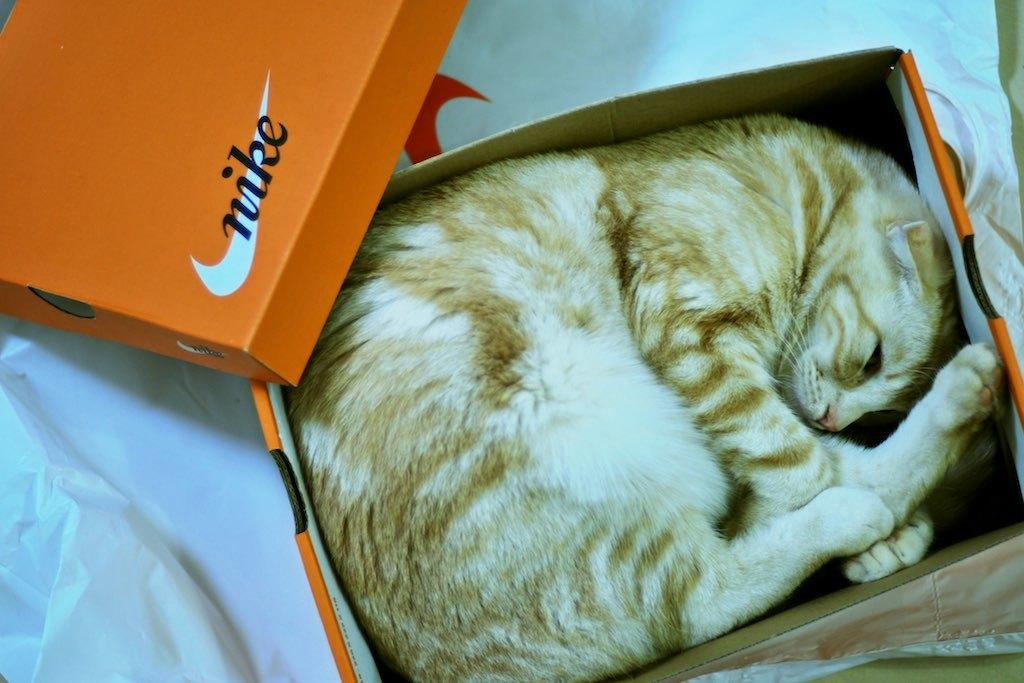What type of animal is in the image? There is a cat in the image. What is the cat doing in the image? The cat is sleeping. Where is the cat located in the image? The cat is in a cardboard box. What is at the bottom of the box? There is a cover at the bottom of the box. How does the cat transport itself to different locations in the image? The cat does not transport itself in the image; it is in a stationary position in the cardboard box. What type of hearing aid is the cat wearing in the image? There is no hearing aid visible on the cat in the image. 